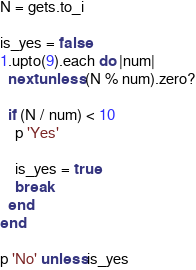<code> <loc_0><loc_0><loc_500><loc_500><_Ruby_>N = gets.to_i

is_yes = false
1.upto(9).each do |num|
  next unless (N % num).zero?

  if (N / num) < 10
    p 'Yes'

    is_yes = true
    break
  end
end

p 'No' unless is_yes
</code> 